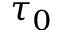Convert formula to latex. <formula><loc_0><loc_0><loc_500><loc_500>\tau _ { 0 }</formula> 